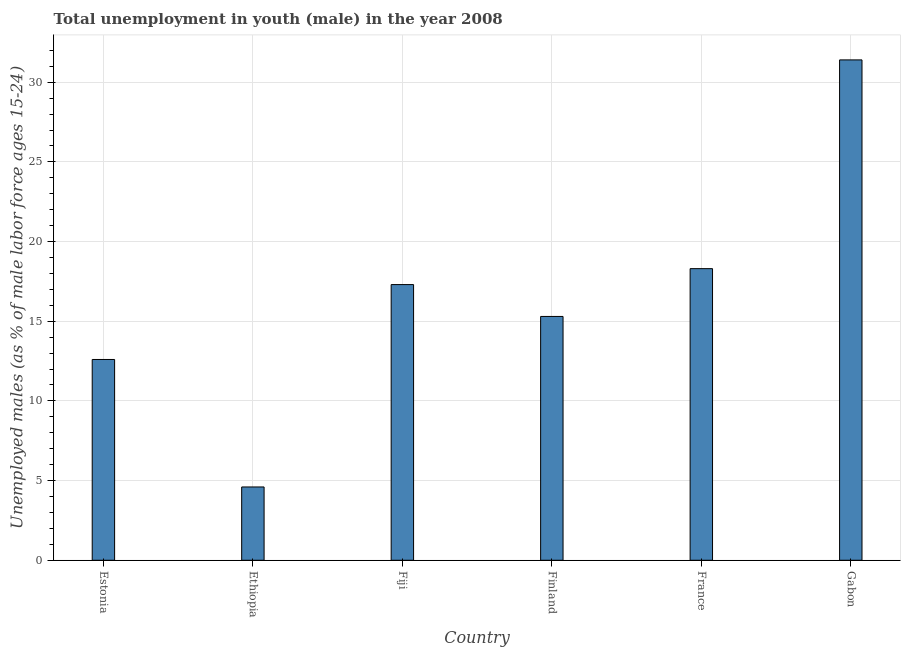Does the graph contain any zero values?
Offer a very short reply. No. Does the graph contain grids?
Your answer should be very brief. Yes. What is the title of the graph?
Offer a terse response. Total unemployment in youth (male) in the year 2008. What is the label or title of the X-axis?
Your response must be concise. Country. What is the label or title of the Y-axis?
Your answer should be compact. Unemployed males (as % of male labor force ages 15-24). What is the unemployed male youth population in France?
Your response must be concise. 18.3. Across all countries, what is the maximum unemployed male youth population?
Your answer should be very brief. 31.4. Across all countries, what is the minimum unemployed male youth population?
Give a very brief answer. 4.6. In which country was the unemployed male youth population maximum?
Offer a very short reply. Gabon. In which country was the unemployed male youth population minimum?
Provide a succinct answer. Ethiopia. What is the sum of the unemployed male youth population?
Keep it short and to the point. 99.5. What is the difference between the unemployed male youth population in Fiji and Gabon?
Make the answer very short. -14.1. What is the average unemployed male youth population per country?
Offer a terse response. 16.58. What is the median unemployed male youth population?
Offer a terse response. 16.3. In how many countries, is the unemployed male youth population greater than 6 %?
Your response must be concise. 5. What is the ratio of the unemployed male youth population in Estonia to that in Ethiopia?
Keep it short and to the point. 2.74. Is the unemployed male youth population in Estonia less than that in France?
Offer a very short reply. Yes. Is the difference between the unemployed male youth population in Finland and Gabon greater than the difference between any two countries?
Give a very brief answer. No. Is the sum of the unemployed male youth population in Finland and Gabon greater than the maximum unemployed male youth population across all countries?
Your answer should be very brief. Yes. What is the difference between the highest and the lowest unemployed male youth population?
Your answer should be very brief. 26.8. How many bars are there?
Give a very brief answer. 6. Are all the bars in the graph horizontal?
Keep it short and to the point. No. How many countries are there in the graph?
Ensure brevity in your answer.  6. What is the Unemployed males (as % of male labor force ages 15-24) of Estonia?
Ensure brevity in your answer.  12.6. What is the Unemployed males (as % of male labor force ages 15-24) of Ethiopia?
Ensure brevity in your answer.  4.6. What is the Unemployed males (as % of male labor force ages 15-24) in Fiji?
Your answer should be very brief. 17.3. What is the Unemployed males (as % of male labor force ages 15-24) of Finland?
Give a very brief answer. 15.3. What is the Unemployed males (as % of male labor force ages 15-24) of France?
Your response must be concise. 18.3. What is the Unemployed males (as % of male labor force ages 15-24) of Gabon?
Make the answer very short. 31.4. What is the difference between the Unemployed males (as % of male labor force ages 15-24) in Estonia and Ethiopia?
Offer a terse response. 8. What is the difference between the Unemployed males (as % of male labor force ages 15-24) in Estonia and Fiji?
Your answer should be compact. -4.7. What is the difference between the Unemployed males (as % of male labor force ages 15-24) in Estonia and France?
Make the answer very short. -5.7. What is the difference between the Unemployed males (as % of male labor force ages 15-24) in Estonia and Gabon?
Provide a succinct answer. -18.8. What is the difference between the Unemployed males (as % of male labor force ages 15-24) in Ethiopia and Fiji?
Your answer should be very brief. -12.7. What is the difference between the Unemployed males (as % of male labor force ages 15-24) in Ethiopia and Finland?
Offer a very short reply. -10.7. What is the difference between the Unemployed males (as % of male labor force ages 15-24) in Ethiopia and France?
Ensure brevity in your answer.  -13.7. What is the difference between the Unemployed males (as % of male labor force ages 15-24) in Ethiopia and Gabon?
Give a very brief answer. -26.8. What is the difference between the Unemployed males (as % of male labor force ages 15-24) in Fiji and Gabon?
Give a very brief answer. -14.1. What is the difference between the Unemployed males (as % of male labor force ages 15-24) in Finland and Gabon?
Make the answer very short. -16.1. What is the difference between the Unemployed males (as % of male labor force ages 15-24) in France and Gabon?
Make the answer very short. -13.1. What is the ratio of the Unemployed males (as % of male labor force ages 15-24) in Estonia to that in Ethiopia?
Provide a short and direct response. 2.74. What is the ratio of the Unemployed males (as % of male labor force ages 15-24) in Estonia to that in Fiji?
Your answer should be compact. 0.73. What is the ratio of the Unemployed males (as % of male labor force ages 15-24) in Estonia to that in Finland?
Keep it short and to the point. 0.82. What is the ratio of the Unemployed males (as % of male labor force ages 15-24) in Estonia to that in France?
Provide a succinct answer. 0.69. What is the ratio of the Unemployed males (as % of male labor force ages 15-24) in Estonia to that in Gabon?
Provide a succinct answer. 0.4. What is the ratio of the Unemployed males (as % of male labor force ages 15-24) in Ethiopia to that in Fiji?
Offer a terse response. 0.27. What is the ratio of the Unemployed males (as % of male labor force ages 15-24) in Ethiopia to that in Finland?
Keep it short and to the point. 0.3. What is the ratio of the Unemployed males (as % of male labor force ages 15-24) in Ethiopia to that in France?
Give a very brief answer. 0.25. What is the ratio of the Unemployed males (as % of male labor force ages 15-24) in Ethiopia to that in Gabon?
Offer a very short reply. 0.15. What is the ratio of the Unemployed males (as % of male labor force ages 15-24) in Fiji to that in Finland?
Keep it short and to the point. 1.13. What is the ratio of the Unemployed males (as % of male labor force ages 15-24) in Fiji to that in France?
Provide a succinct answer. 0.94. What is the ratio of the Unemployed males (as % of male labor force ages 15-24) in Fiji to that in Gabon?
Offer a very short reply. 0.55. What is the ratio of the Unemployed males (as % of male labor force ages 15-24) in Finland to that in France?
Your answer should be very brief. 0.84. What is the ratio of the Unemployed males (as % of male labor force ages 15-24) in Finland to that in Gabon?
Keep it short and to the point. 0.49. What is the ratio of the Unemployed males (as % of male labor force ages 15-24) in France to that in Gabon?
Ensure brevity in your answer.  0.58. 